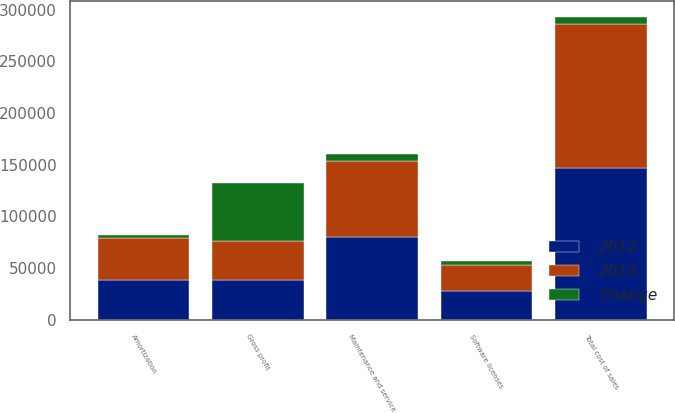<chart> <loc_0><loc_0><loc_500><loc_500><stacked_bar_chart><ecel><fcel>Software licenses<fcel>Amortization<fcel>Maintenance and service<fcel>Total cost of sales<fcel>Gross profit<nl><fcel>2012<fcel>28363<fcel>38298<fcel>80031<fcel>146692<fcel>38298<nl><fcel>2013<fcel>24512<fcel>40889<fcel>74115<fcel>139516<fcel>38298<nl><fcel>Change<fcel>3851<fcel>2591<fcel>5916<fcel>7176<fcel>56066<nl></chart> 